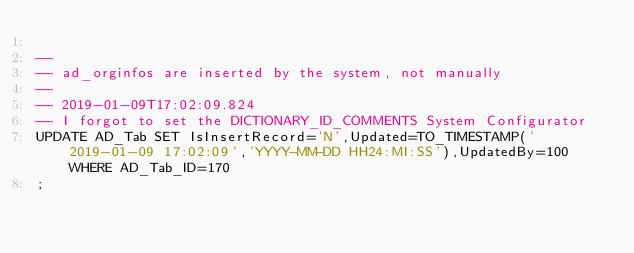<code> <loc_0><loc_0><loc_500><loc_500><_SQL_>
--
-- ad_orginfos are inserted by the system, not manually
--
-- 2019-01-09T17:02:09.824
-- I forgot to set the DICTIONARY_ID_COMMENTS System Configurator
UPDATE AD_Tab SET IsInsertRecord='N',Updated=TO_TIMESTAMP('2019-01-09 17:02:09','YYYY-MM-DD HH24:MI:SS'),UpdatedBy=100 WHERE AD_Tab_ID=170
;

</code> 